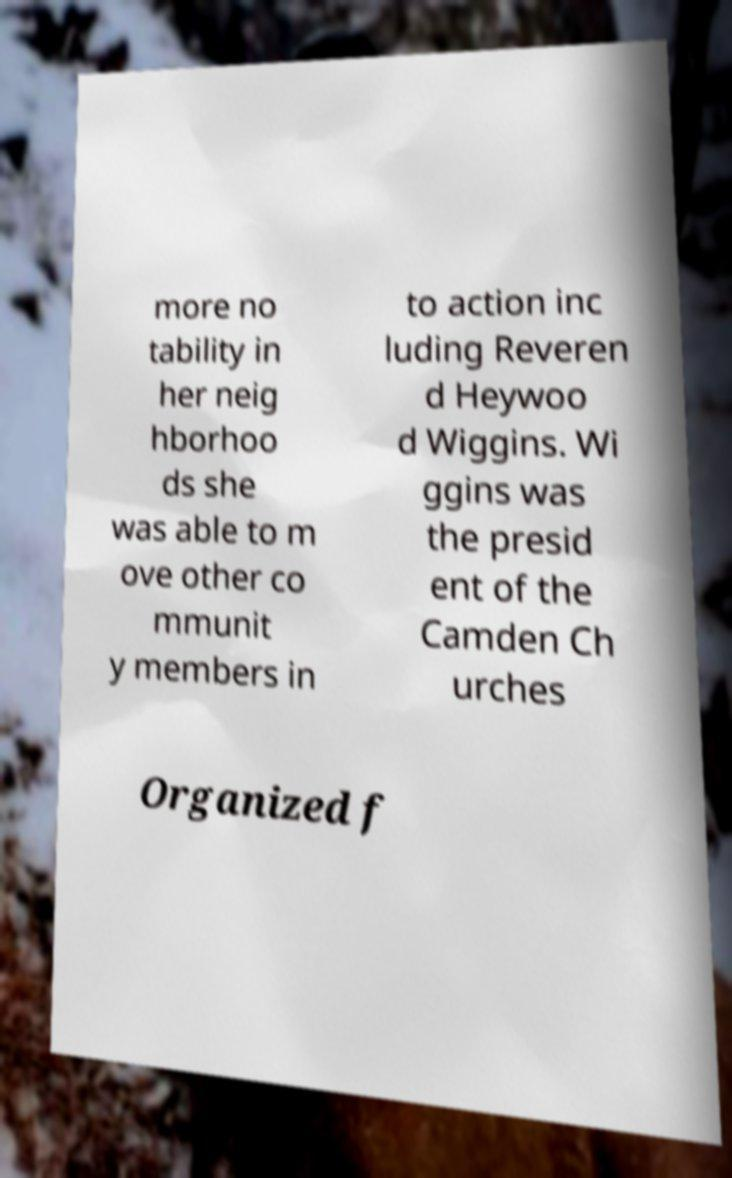Can you accurately transcribe the text from the provided image for me? more no tability in her neig hborhoo ds she was able to m ove other co mmunit y members in to action inc luding Reveren d Heywoo d Wiggins. Wi ggins was the presid ent of the Camden Ch urches Organized f 